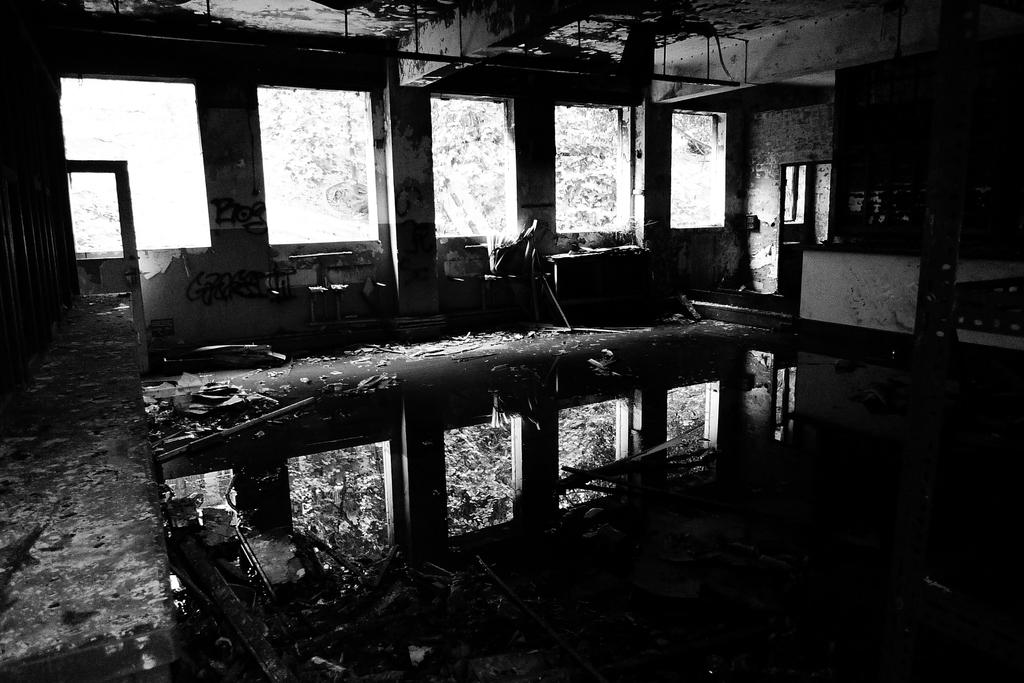What is the color scheme of the image? The image is black and white. What type of location is depicted in the image? The image shows an inside view of a building. What architectural features can be seen in the image? There are windows and pillars in the image. What other objects are present in the image? There are other objects in the image, but their specific details are not mentioned in the provided facts. What type of cart can be seen in the image? There is no cart present in the image. What is the journey of the person in the image? The image does not show a person, so it is not possible to determine the journey of any individual. 